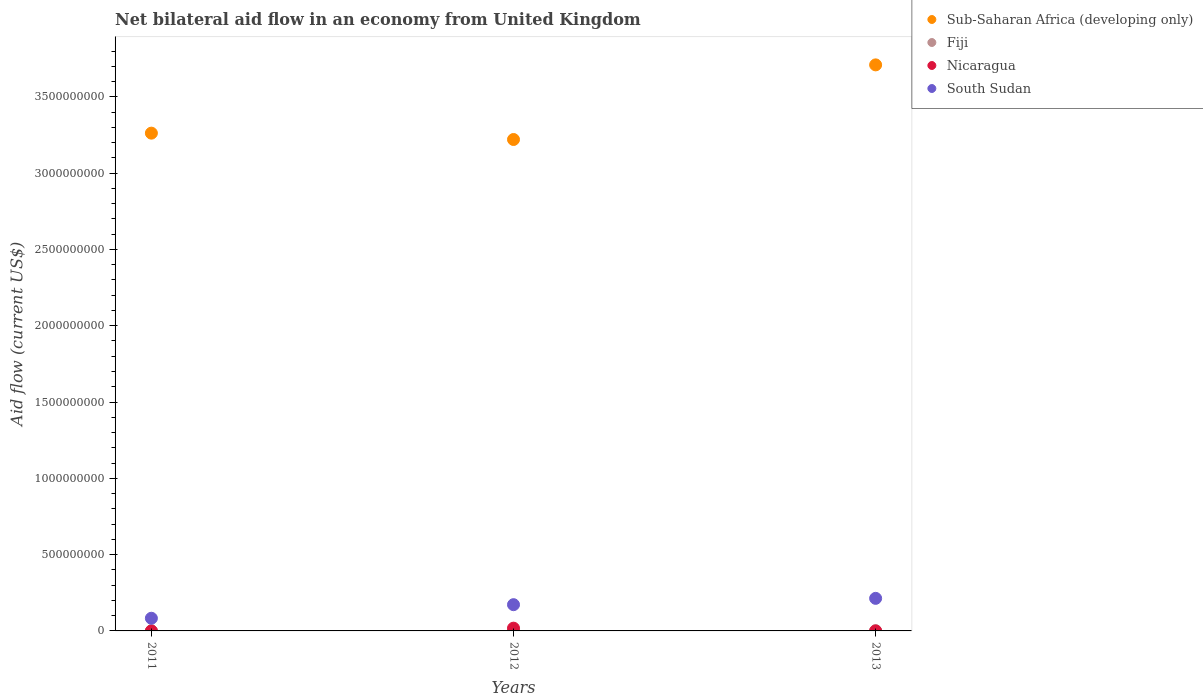How many different coloured dotlines are there?
Your answer should be very brief. 4. Is the number of dotlines equal to the number of legend labels?
Offer a terse response. Yes. What is the net bilateral aid flow in Sub-Saharan Africa (developing only) in 2013?
Make the answer very short. 3.71e+09. Across all years, what is the maximum net bilateral aid flow in Nicaragua?
Provide a short and direct response. 1.81e+07. Across all years, what is the minimum net bilateral aid flow in Sub-Saharan Africa (developing only)?
Provide a short and direct response. 3.22e+09. What is the total net bilateral aid flow in Sub-Saharan Africa (developing only) in the graph?
Provide a short and direct response. 1.02e+1. What is the difference between the net bilateral aid flow in Fiji in 2011 and that in 2012?
Offer a very short reply. -8.50e+05. What is the difference between the net bilateral aid flow in Sub-Saharan Africa (developing only) in 2011 and the net bilateral aid flow in Nicaragua in 2013?
Your answer should be compact. 3.26e+09. What is the average net bilateral aid flow in Sub-Saharan Africa (developing only) per year?
Make the answer very short. 3.40e+09. In the year 2011, what is the difference between the net bilateral aid flow in South Sudan and net bilateral aid flow in Nicaragua?
Provide a short and direct response. 8.30e+07. In how many years, is the net bilateral aid flow in Nicaragua greater than 3000000000 US$?
Make the answer very short. 0. What is the ratio of the net bilateral aid flow in Sub-Saharan Africa (developing only) in 2012 to that in 2013?
Ensure brevity in your answer.  0.87. Is the difference between the net bilateral aid flow in South Sudan in 2011 and 2012 greater than the difference between the net bilateral aid flow in Nicaragua in 2011 and 2012?
Provide a short and direct response. No. What is the difference between the highest and the second highest net bilateral aid flow in South Sudan?
Ensure brevity in your answer.  4.14e+07. What is the difference between the highest and the lowest net bilateral aid flow in Nicaragua?
Provide a short and direct response. 1.80e+07. In how many years, is the net bilateral aid flow in South Sudan greater than the average net bilateral aid flow in South Sudan taken over all years?
Ensure brevity in your answer.  2. Is it the case that in every year, the sum of the net bilateral aid flow in South Sudan and net bilateral aid flow in Nicaragua  is greater than the sum of net bilateral aid flow in Fiji and net bilateral aid flow in Sub-Saharan Africa (developing only)?
Provide a succinct answer. Yes. Is it the case that in every year, the sum of the net bilateral aid flow in Fiji and net bilateral aid flow in Nicaragua  is greater than the net bilateral aid flow in Sub-Saharan Africa (developing only)?
Offer a terse response. No. Does the net bilateral aid flow in Nicaragua monotonically increase over the years?
Offer a terse response. No. Is the net bilateral aid flow in South Sudan strictly greater than the net bilateral aid flow in Sub-Saharan Africa (developing only) over the years?
Offer a very short reply. No. How many years are there in the graph?
Provide a short and direct response. 3. What is the difference between two consecutive major ticks on the Y-axis?
Offer a very short reply. 5.00e+08. Where does the legend appear in the graph?
Your response must be concise. Top right. What is the title of the graph?
Your answer should be compact. Net bilateral aid flow in an economy from United Kingdom. Does "Algeria" appear as one of the legend labels in the graph?
Provide a succinct answer. No. What is the label or title of the Y-axis?
Give a very brief answer. Aid flow (current US$). What is the Aid flow (current US$) of Sub-Saharan Africa (developing only) in 2011?
Your answer should be compact. 3.26e+09. What is the Aid flow (current US$) of Fiji in 2011?
Your answer should be very brief. 2.10e+05. What is the Aid flow (current US$) of Nicaragua in 2011?
Offer a terse response. 3.00e+04. What is the Aid flow (current US$) of South Sudan in 2011?
Give a very brief answer. 8.30e+07. What is the Aid flow (current US$) in Sub-Saharan Africa (developing only) in 2012?
Your answer should be compact. 3.22e+09. What is the Aid flow (current US$) in Fiji in 2012?
Make the answer very short. 1.06e+06. What is the Aid flow (current US$) in Nicaragua in 2012?
Your answer should be compact. 1.81e+07. What is the Aid flow (current US$) of South Sudan in 2012?
Make the answer very short. 1.72e+08. What is the Aid flow (current US$) of Sub-Saharan Africa (developing only) in 2013?
Your answer should be compact. 3.71e+09. What is the Aid flow (current US$) in Fiji in 2013?
Offer a terse response. 1.49e+06. What is the Aid flow (current US$) of Nicaragua in 2013?
Provide a succinct answer. 8.00e+04. What is the Aid flow (current US$) of South Sudan in 2013?
Give a very brief answer. 2.13e+08. Across all years, what is the maximum Aid flow (current US$) in Sub-Saharan Africa (developing only)?
Offer a terse response. 3.71e+09. Across all years, what is the maximum Aid flow (current US$) of Fiji?
Give a very brief answer. 1.49e+06. Across all years, what is the maximum Aid flow (current US$) in Nicaragua?
Offer a very short reply. 1.81e+07. Across all years, what is the maximum Aid flow (current US$) of South Sudan?
Make the answer very short. 2.13e+08. Across all years, what is the minimum Aid flow (current US$) in Sub-Saharan Africa (developing only)?
Ensure brevity in your answer.  3.22e+09. Across all years, what is the minimum Aid flow (current US$) of Fiji?
Your response must be concise. 2.10e+05. Across all years, what is the minimum Aid flow (current US$) in South Sudan?
Your answer should be very brief. 8.30e+07. What is the total Aid flow (current US$) in Sub-Saharan Africa (developing only) in the graph?
Ensure brevity in your answer.  1.02e+1. What is the total Aid flow (current US$) in Fiji in the graph?
Provide a succinct answer. 2.76e+06. What is the total Aid flow (current US$) of Nicaragua in the graph?
Your answer should be compact. 1.82e+07. What is the total Aid flow (current US$) in South Sudan in the graph?
Your answer should be very brief. 4.68e+08. What is the difference between the Aid flow (current US$) in Sub-Saharan Africa (developing only) in 2011 and that in 2012?
Your response must be concise. 4.16e+07. What is the difference between the Aid flow (current US$) in Fiji in 2011 and that in 2012?
Give a very brief answer. -8.50e+05. What is the difference between the Aid flow (current US$) of Nicaragua in 2011 and that in 2012?
Ensure brevity in your answer.  -1.80e+07. What is the difference between the Aid flow (current US$) in South Sudan in 2011 and that in 2012?
Provide a succinct answer. -8.90e+07. What is the difference between the Aid flow (current US$) of Sub-Saharan Africa (developing only) in 2011 and that in 2013?
Offer a very short reply. -4.47e+08. What is the difference between the Aid flow (current US$) in Fiji in 2011 and that in 2013?
Offer a terse response. -1.28e+06. What is the difference between the Aid flow (current US$) of South Sudan in 2011 and that in 2013?
Offer a very short reply. -1.30e+08. What is the difference between the Aid flow (current US$) in Sub-Saharan Africa (developing only) in 2012 and that in 2013?
Offer a terse response. -4.89e+08. What is the difference between the Aid flow (current US$) of Fiji in 2012 and that in 2013?
Provide a succinct answer. -4.30e+05. What is the difference between the Aid flow (current US$) in Nicaragua in 2012 and that in 2013?
Your answer should be very brief. 1.80e+07. What is the difference between the Aid flow (current US$) of South Sudan in 2012 and that in 2013?
Ensure brevity in your answer.  -4.14e+07. What is the difference between the Aid flow (current US$) of Sub-Saharan Africa (developing only) in 2011 and the Aid flow (current US$) of Fiji in 2012?
Your answer should be very brief. 3.26e+09. What is the difference between the Aid flow (current US$) in Sub-Saharan Africa (developing only) in 2011 and the Aid flow (current US$) in Nicaragua in 2012?
Ensure brevity in your answer.  3.24e+09. What is the difference between the Aid flow (current US$) in Sub-Saharan Africa (developing only) in 2011 and the Aid flow (current US$) in South Sudan in 2012?
Ensure brevity in your answer.  3.09e+09. What is the difference between the Aid flow (current US$) in Fiji in 2011 and the Aid flow (current US$) in Nicaragua in 2012?
Provide a succinct answer. -1.79e+07. What is the difference between the Aid flow (current US$) of Fiji in 2011 and the Aid flow (current US$) of South Sudan in 2012?
Provide a succinct answer. -1.72e+08. What is the difference between the Aid flow (current US$) of Nicaragua in 2011 and the Aid flow (current US$) of South Sudan in 2012?
Your answer should be very brief. -1.72e+08. What is the difference between the Aid flow (current US$) of Sub-Saharan Africa (developing only) in 2011 and the Aid flow (current US$) of Fiji in 2013?
Provide a succinct answer. 3.26e+09. What is the difference between the Aid flow (current US$) of Sub-Saharan Africa (developing only) in 2011 and the Aid flow (current US$) of Nicaragua in 2013?
Provide a short and direct response. 3.26e+09. What is the difference between the Aid flow (current US$) of Sub-Saharan Africa (developing only) in 2011 and the Aid flow (current US$) of South Sudan in 2013?
Offer a terse response. 3.05e+09. What is the difference between the Aid flow (current US$) of Fiji in 2011 and the Aid flow (current US$) of South Sudan in 2013?
Provide a succinct answer. -2.13e+08. What is the difference between the Aid flow (current US$) of Nicaragua in 2011 and the Aid flow (current US$) of South Sudan in 2013?
Offer a terse response. -2.13e+08. What is the difference between the Aid flow (current US$) of Sub-Saharan Africa (developing only) in 2012 and the Aid flow (current US$) of Fiji in 2013?
Your response must be concise. 3.22e+09. What is the difference between the Aid flow (current US$) in Sub-Saharan Africa (developing only) in 2012 and the Aid flow (current US$) in Nicaragua in 2013?
Offer a terse response. 3.22e+09. What is the difference between the Aid flow (current US$) of Sub-Saharan Africa (developing only) in 2012 and the Aid flow (current US$) of South Sudan in 2013?
Your answer should be compact. 3.01e+09. What is the difference between the Aid flow (current US$) in Fiji in 2012 and the Aid flow (current US$) in Nicaragua in 2013?
Make the answer very short. 9.80e+05. What is the difference between the Aid flow (current US$) of Fiji in 2012 and the Aid flow (current US$) of South Sudan in 2013?
Provide a short and direct response. -2.12e+08. What is the difference between the Aid flow (current US$) of Nicaragua in 2012 and the Aid flow (current US$) of South Sudan in 2013?
Offer a very short reply. -1.95e+08. What is the average Aid flow (current US$) of Sub-Saharan Africa (developing only) per year?
Provide a succinct answer. 3.40e+09. What is the average Aid flow (current US$) of Fiji per year?
Ensure brevity in your answer.  9.20e+05. What is the average Aid flow (current US$) of Nicaragua per year?
Keep it short and to the point. 6.06e+06. What is the average Aid flow (current US$) of South Sudan per year?
Your answer should be very brief. 1.56e+08. In the year 2011, what is the difference between the Aid flow (current US$) in Sub-Saharan Africa (developing only) and Aid flow (current US$) in Fiji?
Provide a short and direct response. 3.26e+09. In the year 2011, what is the difference between the Aid flow (current US$) in Sub-Saharan Africa (developing only) and Aid flow (current US$) in Nicaragua?
Offer a terse response. 3.26e+09. In the year 2011, what is the difference between the Aid flow (current US$) of Sub-Saharan Africa (developing only) and Aid flow (current US$) of South Sudan?
Provide a succinct answer. 3.18e+09. In the year 2011, what is the difference between the Aid flow (current US$) of Fiji and Aid flow (current US$) of Nicaragua?
Offer a terse response. 1.80e+05. In the year 2011, what is the difference between the Aid flow (current US$) of Fiji and Aid flow (current US$) of South Sudan?
Make the answer very short. -8.28e+07. In the year 2011, what is the difference between the Aid flow (current US$) in Nicaragua and Aid flow (current US$) in South Sudan?
Your response must be concise. -8.30e+07. In the year 2012, what is the difference between the Aid flow (current US$) in Sub-Saharan Africa (developing only) and Aid flow (current US$) in Fiji?
Give a very brief answer. 3.22e+09. In the year 2012, what is the difference between the Aid flow (current US$) in Sub-Saharan Africa (developing only) and Aid flow (current US$) in Nicaragua?
Offer a terse response. 3.20e+09. In the year 2012, what is the difference between the Aid flow (current US$) of Sub-Saharan Africa (developing only) and Aid flow (current US$) of South Sudan?
Your answer should be very brief. 3.05e+09. In the year 2012, what is the difference between the Aid flow (current US$) of Fiji and Aid flow (current US$) of Nicaragua?
Your answer should be very brief. -1.70e+07. In the year 2012, what is the difference between the Aid flow (current US$) in Fiji and Aid flow (current US$) in South Sudan?
Keep it short and to the point. -1.71e+08. In the year 2012, what is the difference between the Aid flow (current US$) of Nicaragua and Aid flow (current US$) of South Sudan?
Provide a short and direct response. -1.54e+08. In the year 2013, what is the difference between the Aid flow (current US$) of Sub-Saharan Africa (developing only) and Aid flow (current US$) of Fiji?
Provide a short and direct response. 3.71e+09. In the year 2013, what is the difference between the Aid flow (current US$) in Sub-Saharan Africa (developing only) and Aid flow (current US$) in Nicaragua?
Your answer should be compact. 3.71e+09. In the year 2013, what is the difference between the Aid flow (current US$) of Sub-Saharan Africa (developing only) and Aid flow (current US$) of South Sudan?
Keep it short and to the point. 3.50e+09. In the year 2013, what is the difference between the Aid flow (current US$) in Fiji and Aid flow (current US$) in Nicaragua?
Your response must be concise. 1.41e+06. In the year 2013, what is the difference between the Aid flow (current US$) of Fiji and Aid flow (current US$) of South Sudan?
Provide a short and direct response. -2.12e+08. In the year 2013, what is the difference between the Aid flow (current US$) in Nicaragua and Aid flow (current US$) in South Sudan?
Your response must be concise. -2.13e+08. What is the ratio of the Aid flow (current US$) of Sub-Saharan Africa (developing only) in 2011 to that in 2012?
Your answer should be compact. 1.01. What is the ratio of the Aid flow (current US$) of Fiji in 2011 to that in 2012?
Provide a short and direct response. 0.2. What is the ratio of the Aid flow (current US$) of Nicaragua in 2011 to that in 2012?
Give a very brief answer. 0. What is the ratio of the Aid flow (current US$) in South Sudan in 2011 to that in 2012?
Your response must be concise. 0.48. What is the ratio of the Aid flow (current US$) in Sub-Saharan Africa (developing only) in 2011 to that in 2013?
Provide a succinct answer. 0.88. What is the ratio of the Aid flow (current US$) in Fiji in 2011 to that in 2013?
Keep it short and to the point. 0.14. What is the ratio of the Aid flow (current US$) in South Sudan in 2011 to that in 2013?
Your response must be concise. 0.39. What is the ratio of the Aid flow (current US$) of Sub-Saharan Africa (developing only) in 2012 to that in 2013?
Your answer should be compact. 0.87. What is the ratio of the Aid flow (current US$) in Fiji in 2012 to that in 2013?
Make the answer very short. 0.71. What is the ratio of the Aid flow (current US$) in Nicaragua in 2012 to that in 2013?
Keep it short and to the point. 225.88. What is the ratio of the Aid flow (current US$) of South Sudan in 2012 to that in 2013?
Give a very brief answer. 0.81. What is the difference between the highest and the second highest Aid flow (current US$) in Sub-Saharan Africa (developing only)?
Offer a terse response. 4.47e+08. What is the difference between the highest and the second highest Aid flow (current US$) in Fiji?
Your answer should be compact. 4.30e+05. What is the difference between the highest and the second highest Aid flow (current US$) in Nicaragua?
Offer a terse response. 1.80e+07. What is the difference between the highest and the second highest Aid flow (current US$) of South Sudan?
Make the answer very short. 4.14e+07. What is the difference between the highest and the lowest Aid flow (current US$) in Sub-Saharan Africa (developing only)?
Offer a very short reply. 4.89e+08. What is the difference between the highest and the lowest Aid flow (current US$) in Fiji?
Offer a very short reply. 1.28e+06. What is the difference between the highest and the lowest Aid flow (current US$) of Nicaragua?
Your answer should be very brief. 1.80e+07. What is the difference between the highest and the lowest Aid flow (current US$) in South Sudan?
Provide a short and direct response. 1.30e+08. 